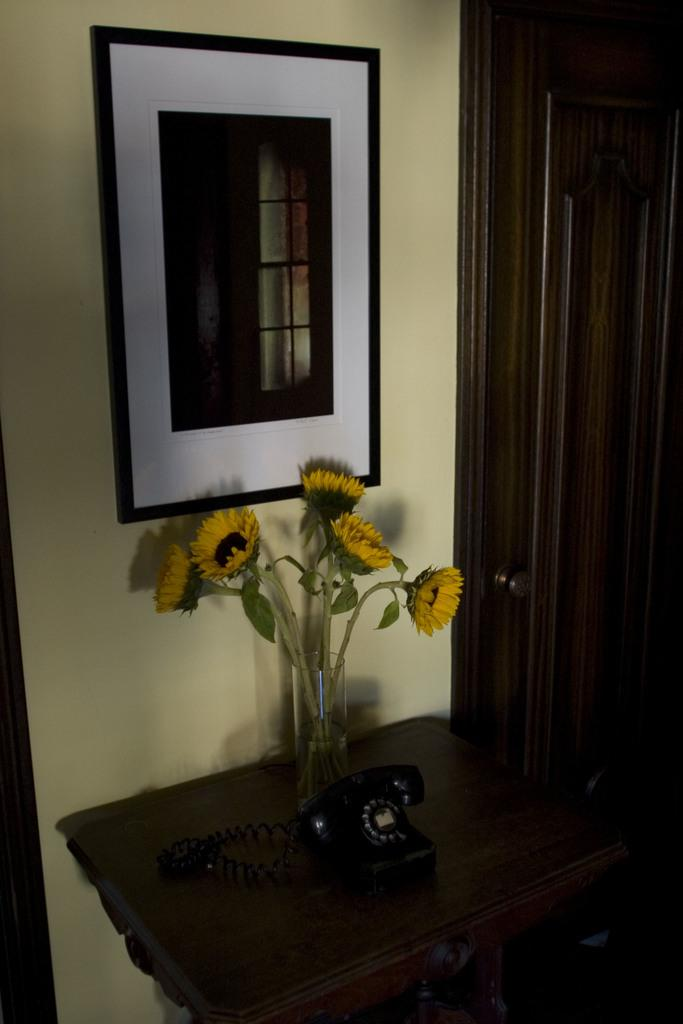What is the main object in the center of the image? There is a table in the center of the image. What electronic device is on the table? A land phone is present on the table. What decorative item is on the table? There is a flower vase on the table. What architectural features can be seen in the background of the image? There is a wall and a door in the background of the image. What type of object is hanging on the wall in the background? A photo frame is visible in the background of the image. What type of drug is being prepared on the table in the image? There is no drug present in the image; the table contains a land phone and a flower vase. What type of meal is being served on the table in the image? There is no meal present in the image; the table contains a land phone and a flower vase. 